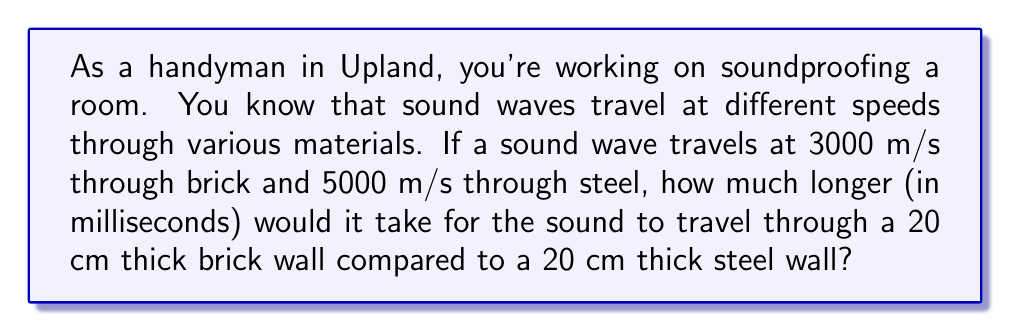Can you solve this math problem? Let's approach this step-by-step:

1) First, we need to understand that time is equal to distance divided by speed. The formula is:

   $t = \frac{d}{v}$

   where $t$ is time, $d$ is distance, and $v$ is velocity.

2) For the brick wall:
   $t_{brick} = \frac{0.20 \text{ m}}{3000 \text{ m/s}} = 6.67 \times 10^{-5} \text{ s}$

3) For the steel wall:
   $t_{steel} = \frac{0.20 \text{ m}}{5000 \text{ m/s}} = 4 \times 10^{-5} \text{ s}$

4) The difference in time is:
   $\Delta t = t_{brick} - t_{steel} = (6.67 \times 10^{-5} - 4 \times 10^{-5}) \text{ s} = 2.67 \times 10^{-5} \text{ s}$

5) To convert this to milliseconds, we multiply by 1000:
   $2.67 \times 10^{-5} \text{ s} \times 1000 = 0.0267 \text{ ms}$

Therefore, sound would take about 0.0267 milliseconds longer to travel through the brick wall compared to the steel wall.
Answer: 0.0267 ms 